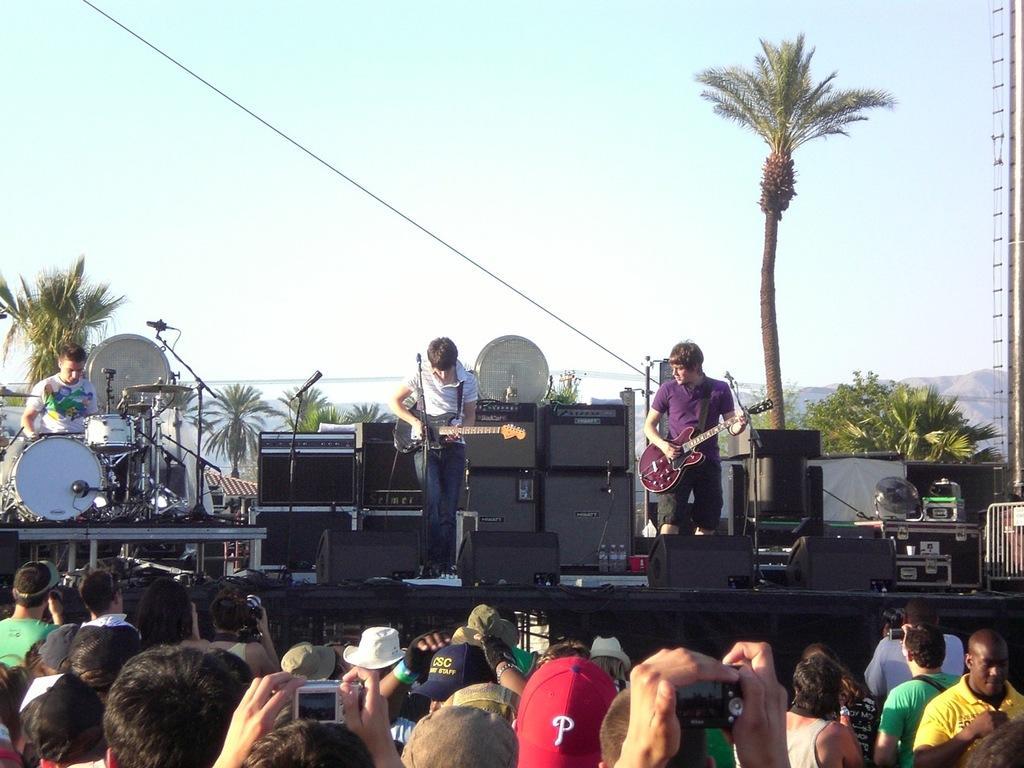Could you give a brief overview of what you see in this image? In this image there are group of persons in the front standing. In the center there are musicians performing on the stage and there are musical instruments on the stage. In the background there are trees. In the front there are persons holding camera. 